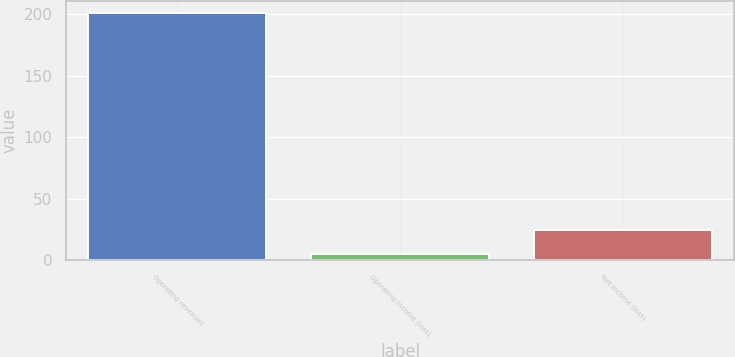Convert chart to OTSL. <chart><loc_0><loc_0><loc_500><loc_500><bar_chart><fcel>Operating revenues<fcel>Operating income (loss)<fcel>Net income (loss)<nl><fcel>201<fcel>5<fcel>24.6<nl></chart> 